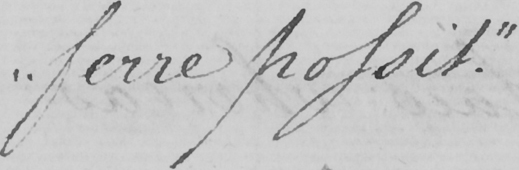Please provide the text content of this handwritten line. " ferre possit . " 